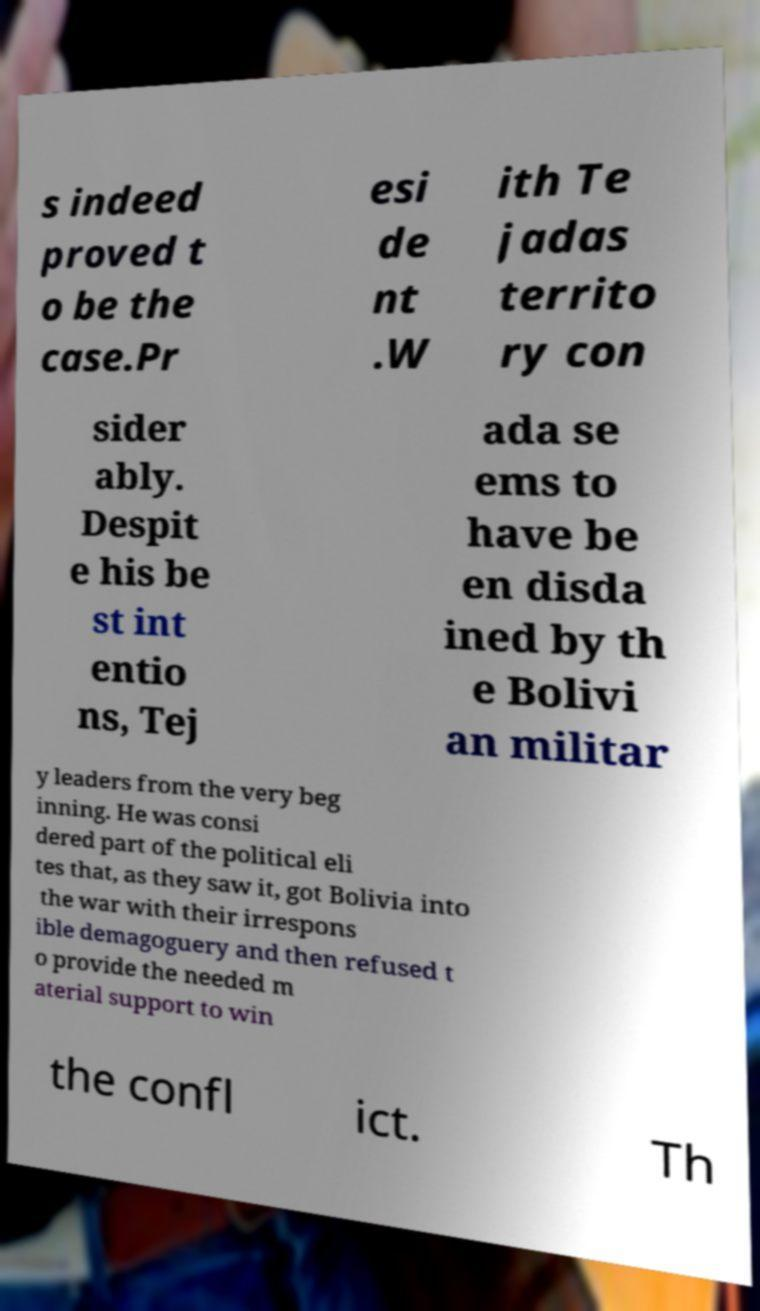Please read and relay the text visible in this image. What does it say? s indeed proved t o be the case.Pr esi de nt .W ith Te jadas territo ry con sider ably. Despit e his be st int entio ns, Tej ada se ems to have be en disda ined by th e Bolivi an militar y leaders from the very beg inning. He was consi dered part of the political eli tes that, as they saw it, got Bolivia into the war with their irrespons ible demagoguery and then refused t o provide the needed m aterial support to win the confl ict. Th 